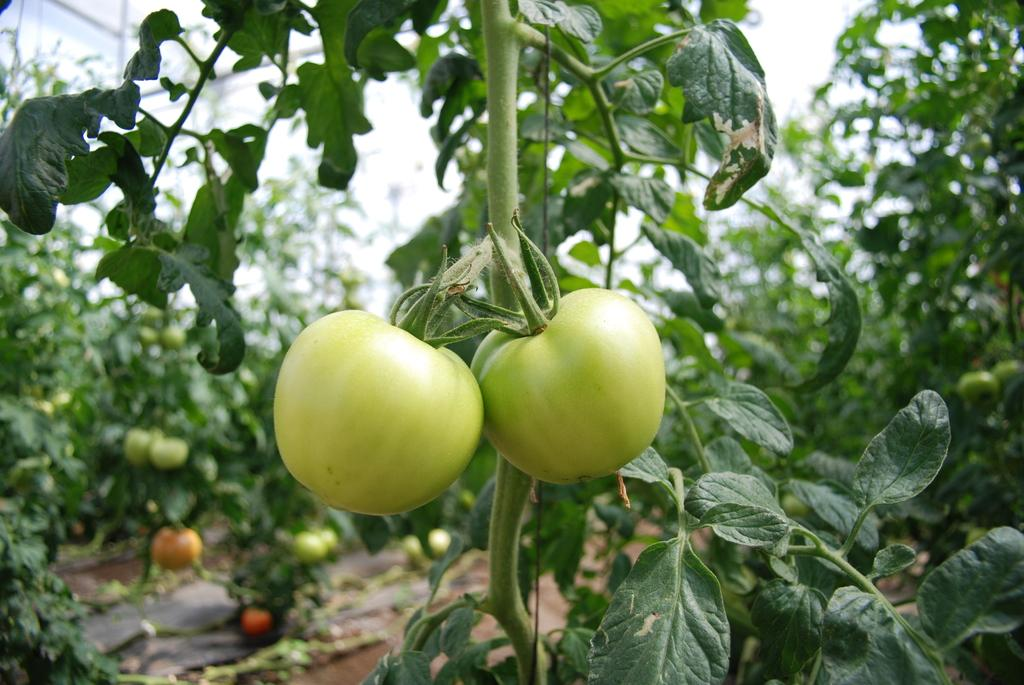What type of food can be seen in the image? There are vegetables in the image. Where are the vegetables located? The vegetables are on plants. What colors can be observed in the vegetables? The vegetables have brown, orange, and red colors. What is visible in the background of the image? The sky is visible in the background of the image. What color is the sky in the image? The sky is white in the image. What type of property does the committee own in the image? There is no mention of a committee or property in the image; it features vegetables on plants with a white sky in the background. 